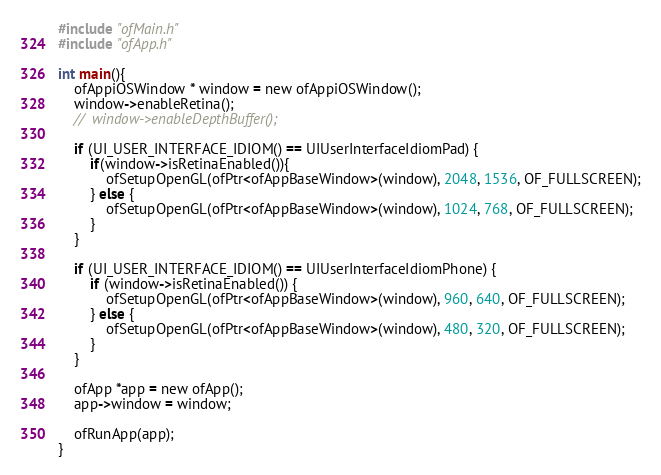<code> <loc_0><loc_0><loc_500><loc_500><_ObjectiveC_>#include "ofMain.h"
#include "ofApp.h"

int main(){
    ofAppiOSWindow * window = new ofAppiOSWindow();
    window->enableRetina();
    //  window->enableDepthBuffer();
    
    if (UI_USER_INTERFACE_IDIOM() == UIUserInterfaceIdiomPad) {
        if(window->isRetinaEnabled()){
            ofSetupOpenGL(ofPtr<ofAppBaseWindow>(window), 2048, 1536, OF_FULLSCREEN);
        } else {
            ofSetupOpenGL(ofPtr<ofAppBaseWindow>(window), 1024, 768, OF_FULLSCREEN);
        }
    }
    
    if (UI_USER_INTERFACE_IDIOM() == UIUserInterfaceIdiomPhone) {
        if (window->isRetinaEnabled()) {
            ofSetupOpenGL(ofPtr<ofAppBaseWindow>(window), 960, 640, OF_FULLSCREEN);
        } else {
            ofSetupOpenGL(ofPtr<ofAppBaseWindow>(window), 480, 320, OF_FULLSCREEN);
        }
    }
    
    ofApp *app = new ofApp();
    app->window = window;
    
	ofRunApp(app);
}
</code> 